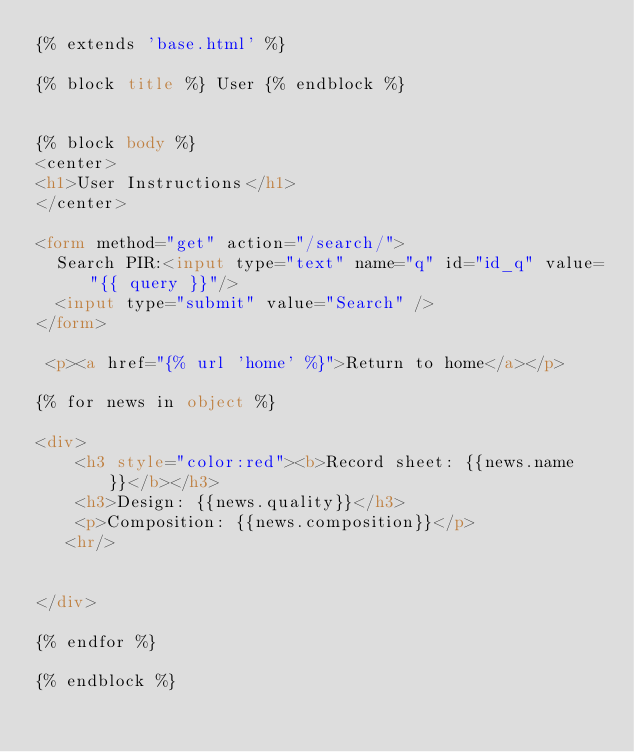<code> <loc_0><loc_0><loc_500><loc_500><_HTML_>{% extends 'base.html' %}
 
{% block title %} User {% endblock %}
 
 
{% block body %}
<center> 
<h1>User Instructions</h1>
</center>

<form method="get" action="/search/">
  Search PIR:<input type="text" name="q" id="id_q" value="{{ query }}"/>
  <input type="submit" value="Search" />
</form>

 <p><a href="{% url 'home' %}">Return to home</a></p>

{% for news in object %}

<div>
    <h3 style="color:red"><b>Record sheet: {{news.name}}</b></h3>
    <h3>Design: {{news.quality}}</h3>
    <p>Composition: {{news.composition}}</p>
   <hr/>


</div>

{% endfor %}
 
{% endblock %}
</code> 